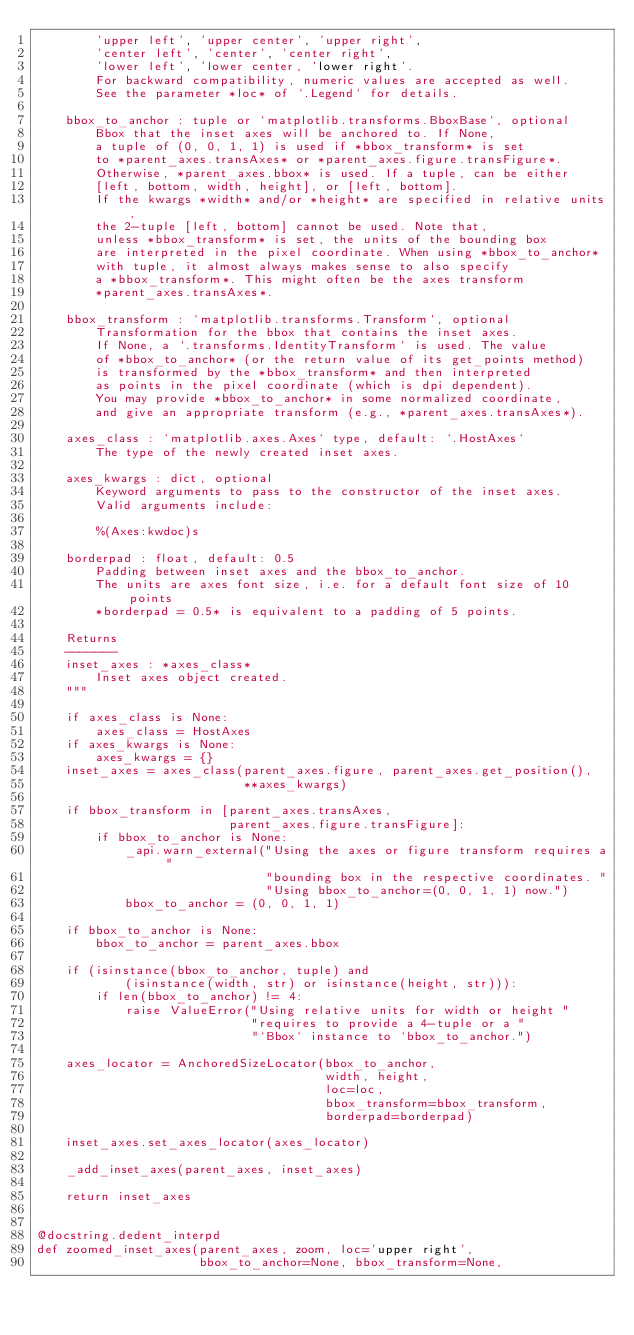<code> <loc_0><loc_0><loc_500><loc_500><_Python_>        'upper left', 'upper center', 'upper right',
        'center left', 'center', 'center right',
        'lower left', 'lower center, 'lower right'.
        For backward compatibility, numeric values are accepted as well.
        See the parameter *loc* of `.Legend` for details.

    bbox_to_anchor : tuple or `matplotlib.transforms.BboxBase`, optional
        Bbox that the inset axes will be anchored to. If None,
        a tuple of (0, 0, 1, 1) is used if *bbox_transform* is set
        to *parent_axes.transAxes* or *parent_axes.figure.transFigure*.
        Otherwise, *parent_axes.bbox* is used. If a tuple, can be either
        [left, bottom, width, height], or [left, bottom].
        If the kwargs *width* and/or *height* are specified in relative units,
        the 2-tuple [left, bottom] cannot be used. Note that,
        unless *bbox_transform* is set, the units of the bounding box
        are interpreted in the pixel coordinate. When using *bbox_to_anchor*
        with tuple, it almost always makes sense to also specify
        a *bbox_transform*. This might often be the axes transform
        *parent_axes.transAxes*.

    bbox_transform : `matplotlib.transforms.Transform`, optional
        Transformation for the bbox that contains the inset axes.
        If None, a `.transforms.IdentityTransform` is used. The value
        of *bbox_to_anchor* (or the return value of its get_points method)
        is transformed by the *bbox_transform* and then interpreted
        as points in the pixel coordinate (which is dpi dependent).
        You may provide *bbox_to_anchor* in some normalized coordinate,
        and give an appropriate transform (e.g., *parent_axes.transAxes*).

    axes_class : `matplotlib.axes.Axes` type, default: `.HostAxes`
        The type of the newly created inset axes.

    axes_kwargs : dict, optional
        Keyword arguments to pass to the constructor of the inset axes.
        Valid arguments include:

        %(Axes:kwdoc)s

    borderpad : float, default: 0.5
        Padding between inset axes and the bbox_to_anchor.
        The units are axes font size, i.e. for a default font size of 10 points
        *borderpad = 0.5* is equivalent to a padding of 5 points.

    Returns
    -------
    inset_axes : *axes_class*
        Inset axes object created.
    """

    if axes_class is None:
        axes_class = HostAxes
    if axes_kwargs is None:
        axes_kwargs = {}
    inset_axes = axes_class(parent_axes.figure, parent_axes.get_position(),
                            **axes_kwargs)

    if bbox_transform in [parent_axes.transAxes,
                          parent_axes.figure.transFigure]:
        if bbox_to_anchor is None:
            _api.warn_external("Using the axes or figure transform requires a "
                               "bounding box in the respective coordinates. "
                               "Using bbox_to_anchor=(0, 0, 1, 1) now.")
            bbox_to_anchor = (0, 0, 1, 1)

    if bbox_to_anchor is None:
        bbox_to_anchor = parent_axes.bbox

    if (isinstance(bbox_to_anchor, tuple) and
            (isinstance(width, str) or isinstance(height, str))):
        if len(bbox_to_anchor) != 4:
            raise ValueError("Using relative units for width or height "
                             "requires to provide a 4-tuple or a "
                             "`Bbox` instance to `bbox_to_anchor.")

    axes_locator = AnchoredSizeLocator(bbox_to_anchor,
                                       width, height,
                                       loc=loc,
                                       bbox_transform=bbox_transform,
                                       borderpad=borderpad)

    inset_axes.set_axes_locator(axes_locator)

    _add_inset_axes(parent_axes, inset_axes)

    return inset_axes


@docstring.dedent_interpd
def zoomed_inset_axes(parent_axes, zoom, loc='upper right',
                      bbox_to_anchor=None, bbox_transform=None,</code> 